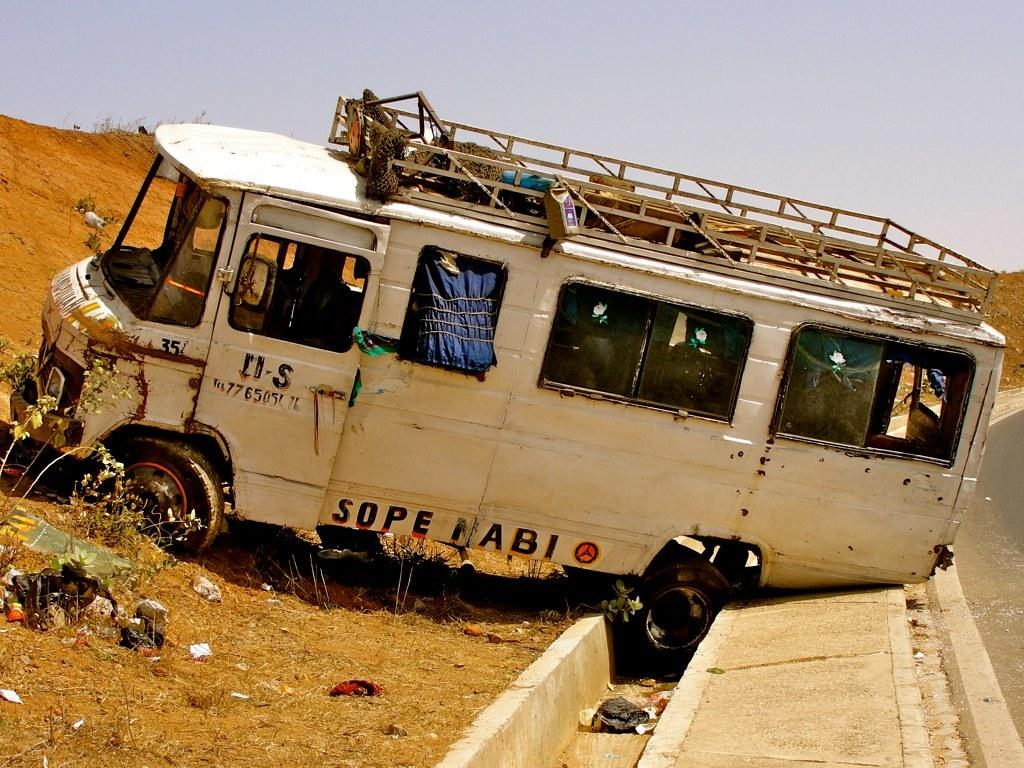What vehicle is in the picture? There is a van in the picture. What is the situation of the van in the image? The van is stuck between walls and part of it is on a muddy slope. What can be seen at the top of the muddy slope? The sky is visible at the top of the muddy slope. What type of education can be seen being provided to the birds in the image? There are no birds present in the image, and therefore no education is being provided to them. 